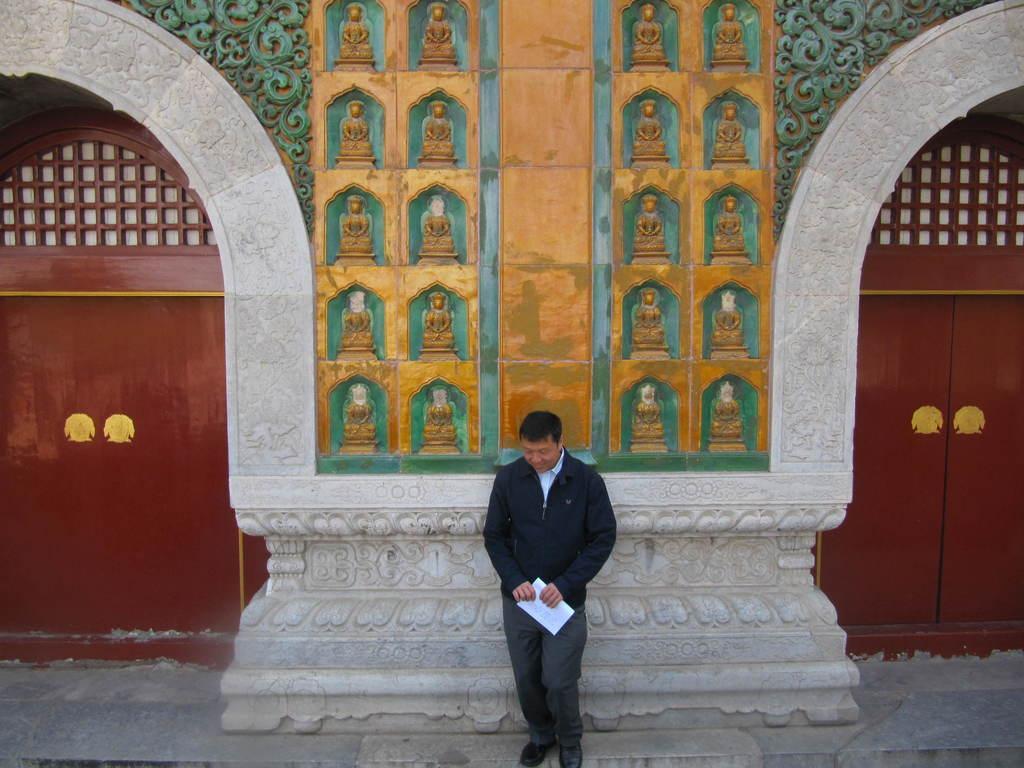How would you summarize this image in a sentence or two? In the image we can see there is a person standing and he is holding paper in his hand. Behind there is a building and there are statues of people sitting. There are doors at the back. 